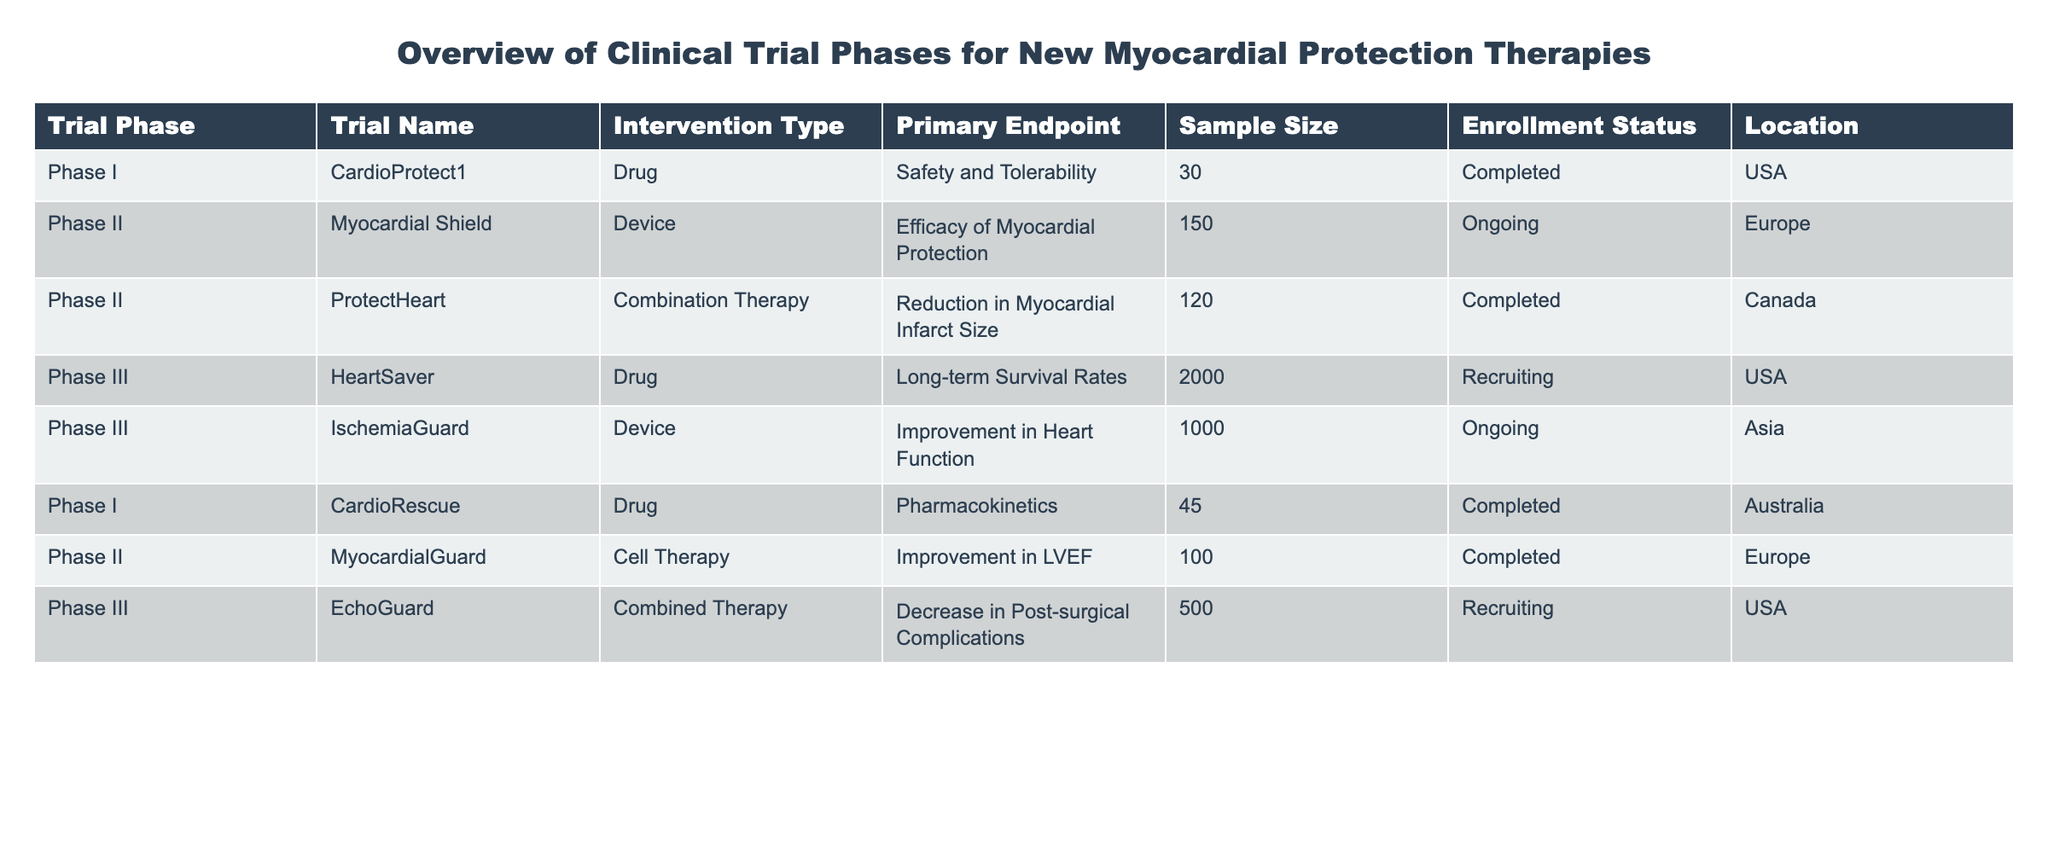What is the sample size of the trial named "ProtectHeart"? The table lists the trial "ProtectHeart" under Phase II, with a sample size specified in the second column. According to the table, the sample size for "ProtectHeart" is 120.
Answer: 120 How many trials are currently recruiting participants? To determine the number of trials currently recruiting, we need to look at the "Enrollment Status" column and count the entries marked as "Recruiting." There are two trials with this status: "HeartSaver" and "EchoGuard."
Answer: 2 Which trial has the highest sample size? We examine the "Sample Size" column and identify the maximum value. The largest sample size noted in the table is 2000 for the "HeartSaver" trial.
Answer: 2000 Are there any Phase I trials that are ongoing? The "Enrollment Status" column must be checked for any "Ongoing" entries under the "Phase I" row. Looking through the list, we find that both Phase I trials are "Completed," so the answer is no.
Answer: No What is the primary endpoint of the trial "IschemiaGuard"? The "Primary Endpoint" for the trial "IschemiaGuard" is located in the corresponding row in the table. It specifies "Improvement in Heart Function" as the primary endpoint.
Answer: Improvement in Heart Function How many trials use a device as an intervention type? We need to count the entries in the "Intervention Type" column that are labeled as "Device." Upon reviewing the table, there are three such trials: "Myocardial Shield," "IschemiaGuard," and "CardioRescue."
Answer: 3 What is the average sample size across all trials? To find the average sample size, we first sum all the sample sizes: 30 + 150 + 120 + 2000 + 1000 + 45 + 100 + 500 = 2945. Next, we divide by the number of trials listed, which is 8. 2945 divided by 8 equals approximately 368.125.
Answer: 368.125 Which trial is the only combination therapy in Phase II? By looking through Phase II trials, we check for "Combination Therapy" in the "Intervention Type" column. The "ProtectHeart" trial is the only one fitting this description for Phase II.
Answer: ProtectHeart Is there any trial located in Australia? We can find out if there is an "Australia" entry in the "Location" column. The table confirms that "CardioRescue" is the trial listed in Australia.
Answer: Yes What percentage of trials completed enrollment status compared to total trials? First, we count the number of completed trials: "CardioProtect1," "ProtectHeart," "CardioRescue," and "MyocardialGuard," totaling 4. The total number of trials is 8. Thus, the percentage is (4/8)*100 = 50%.
Answer: 50% 